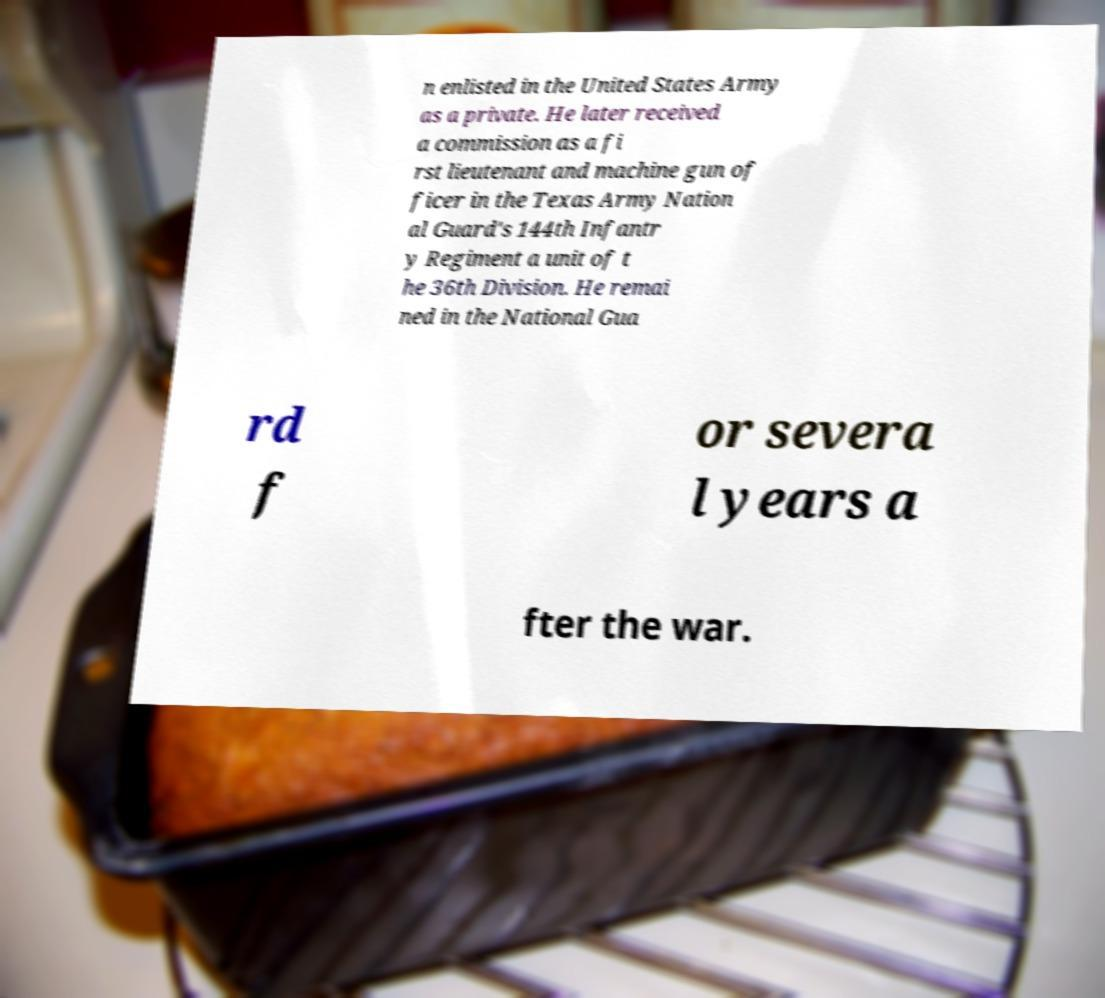What messages or text are displayed in this image? I need them in a readable, typed format. n enlisted in the United States Army as a private. He later received a commission as a fi rst lieutenant and machine gun of ficer in the Texas Army Nation al Guard's 144th Infantr y Regiment a unit of t he 36th Division. He remai ned in the National Gua rd f or severa l years a fter the war. 